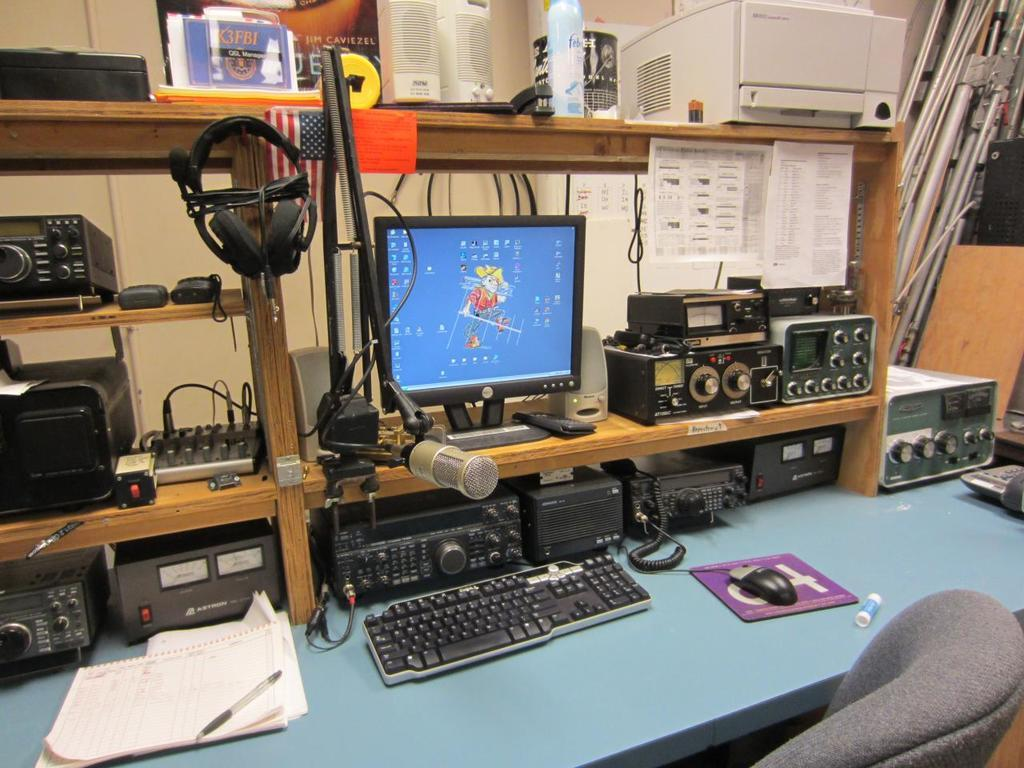What type of electronic devices can be seen in the room? There are computers in the room. What are the input devices for the computers? Keyboards and mice are visible in the room. What accessories are available for audio communication? Headsets are in the room. What stationery items can be found in the room? There are papers and pens present in the room. What furniture is in the room for seating and working? There is a table and chairs in the room. What type of beef dish is being served at the party in the image? There is no party or beef dish present in the image; it features a room with computers, keyboards, mice, headsets, papers, pens, a table, and chairs. Can you tell me how many turkeys are visible in the image? There are no turkeys present in the image. 